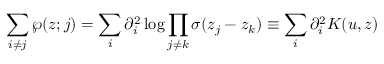Convert formula to latex. <formula><loc_0><loc_0><loc_500><loc_500>\sum _ { i \neq j } \wp ( z ; j ) = \sum _ { i } \partial _ { i } ^ { 2 } \log \prod _ { j \neq k } \sigma ( z _ { j } - z _ { k } ) \equiv \sum _ { i } \partial _ { i } ^ { 2 } K ( u , z )</formula> 